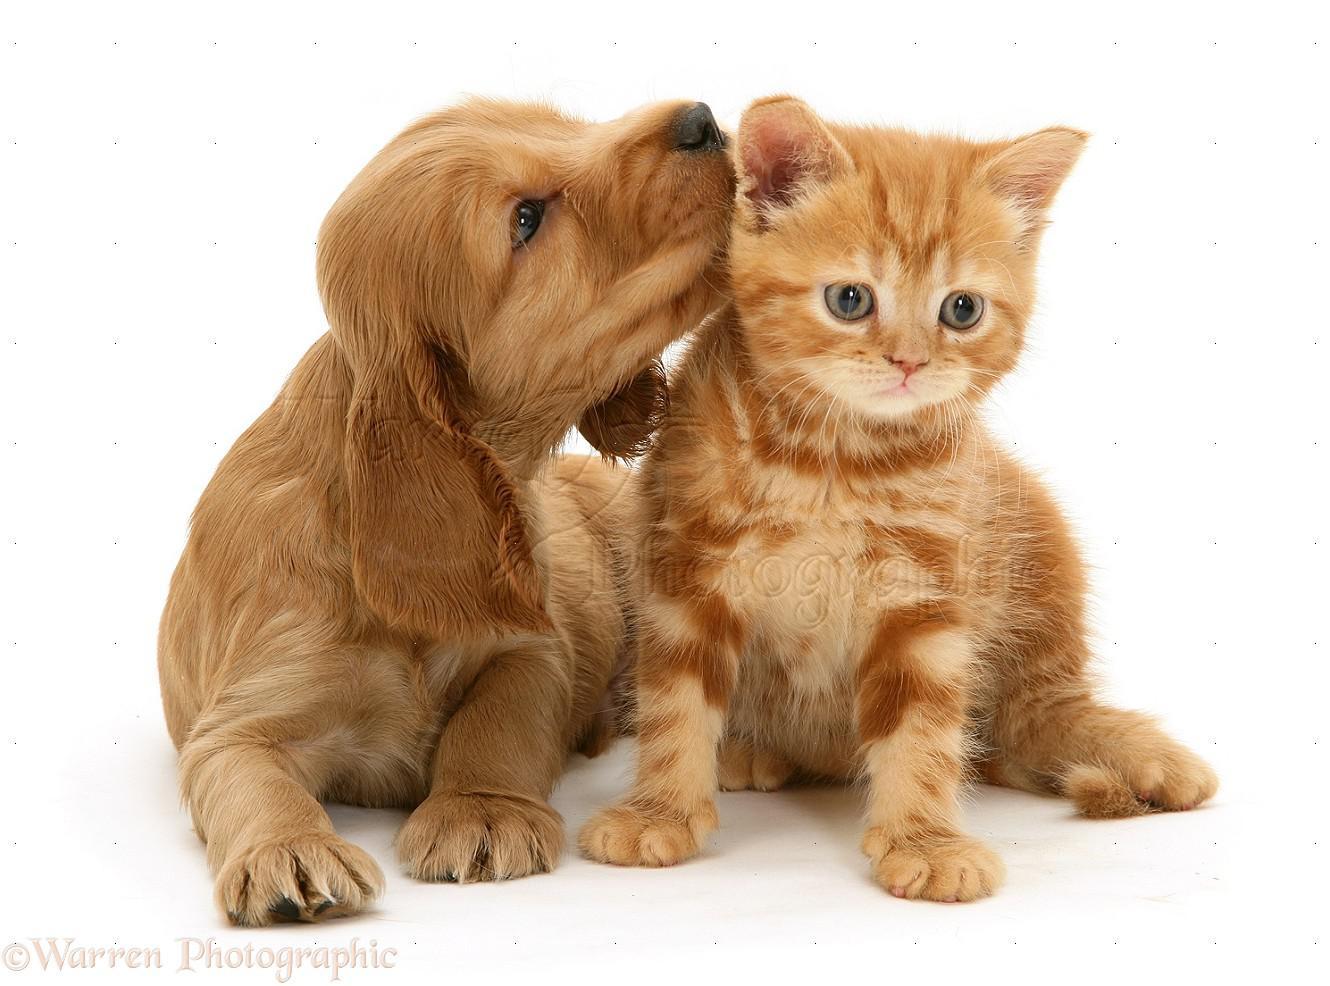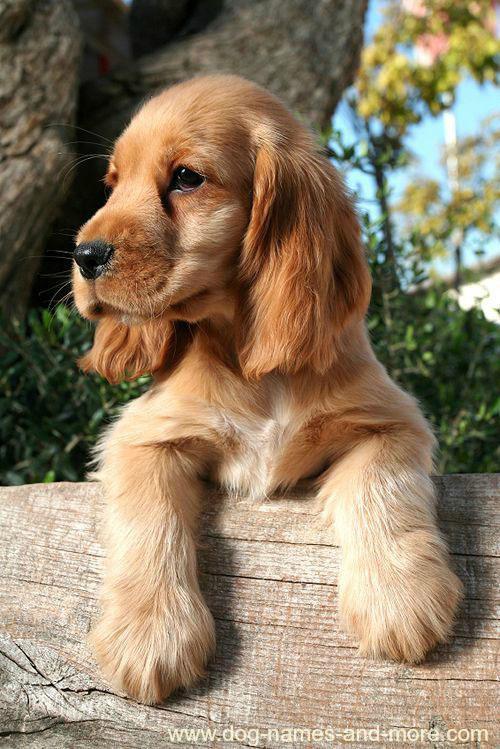The first image is the image on the left, the second image is the image on the right. Analyze the images presented: Is the assertion "A spaniel puppy is posed next to a different animal pet in the left image, and the right image shows an orange spaniel with front paws forward." valid? Answer yes or no. Yes. The first image is the image on the left, the second image is the image on the right. Examine the images to the left and right. Is the description "A dog is sitting with a dog of another species in the image on the left." accurate? Answer yes or no. Yes. 